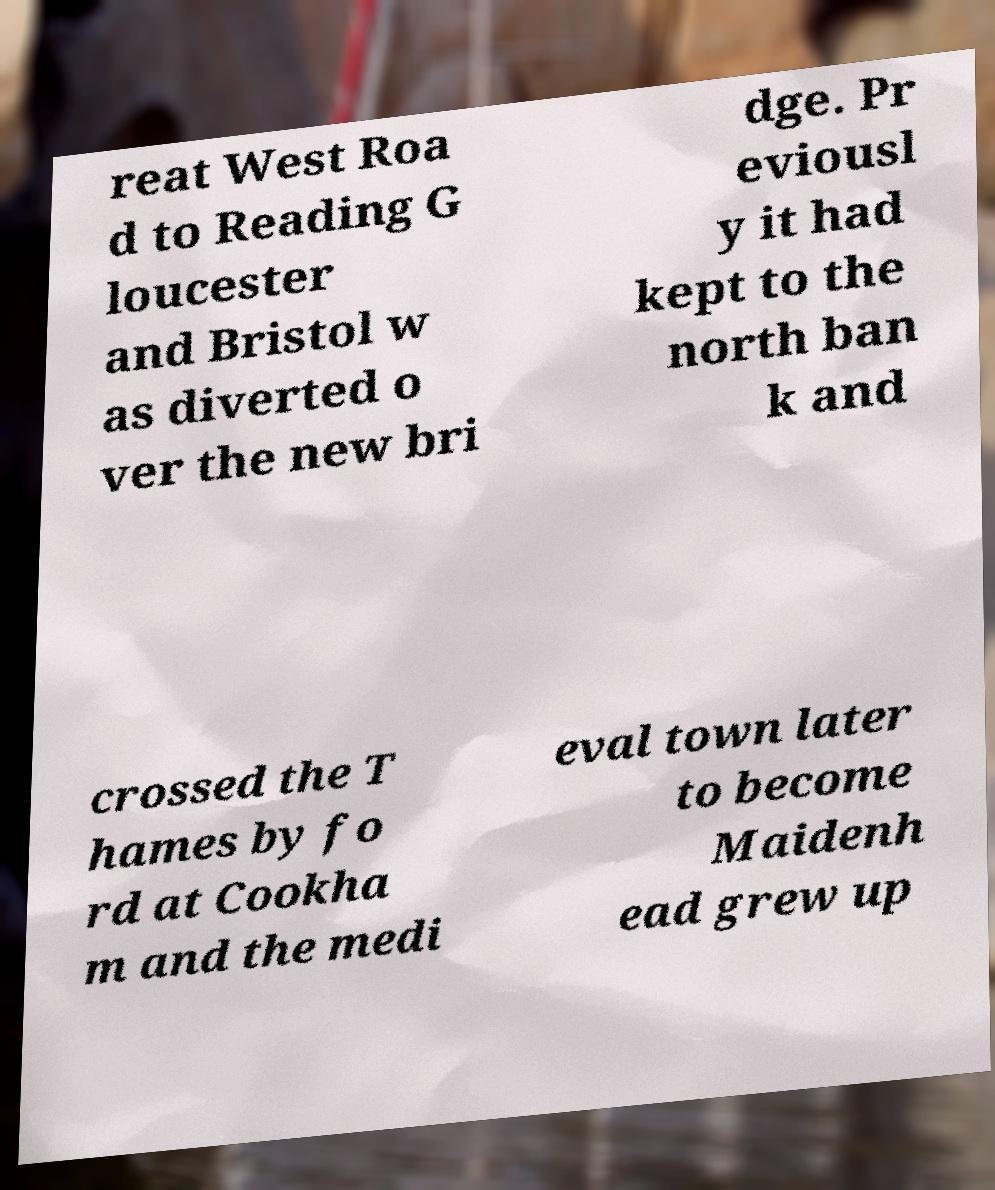Could you extract and type out the text from this image? reat West Roa d to Reading G loucester and Bristol w as diverted o ver the new bri dge. Pr eviousl y it had kept to the north ban k and crossed the T hames by fo rd at Cookha m and the medi eval town later to become Maidenh ead grew up 